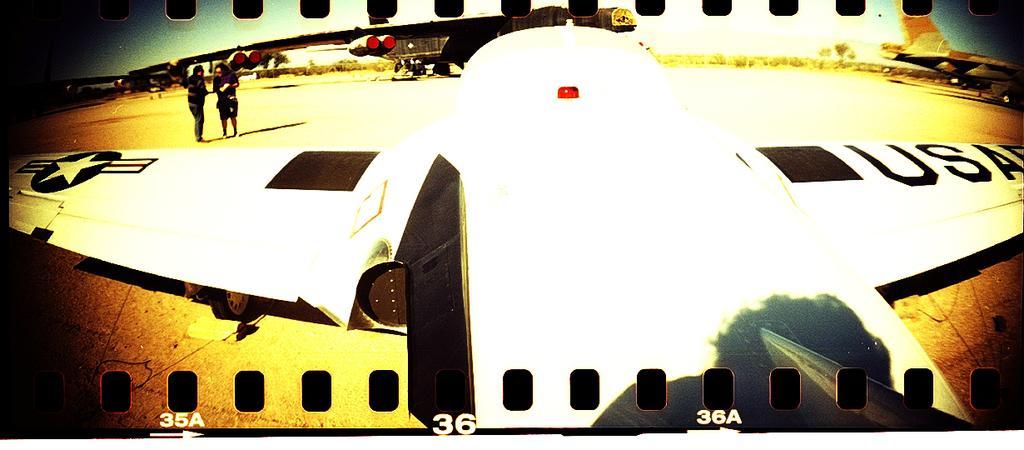Describe this image in one or two sentences. In this image we can see a picture in which we can see some airplanes placed on the ground. On the left side of the image we can see two men standing. In the background, we can see a group of trees. At the top of the image we can see the sky. 